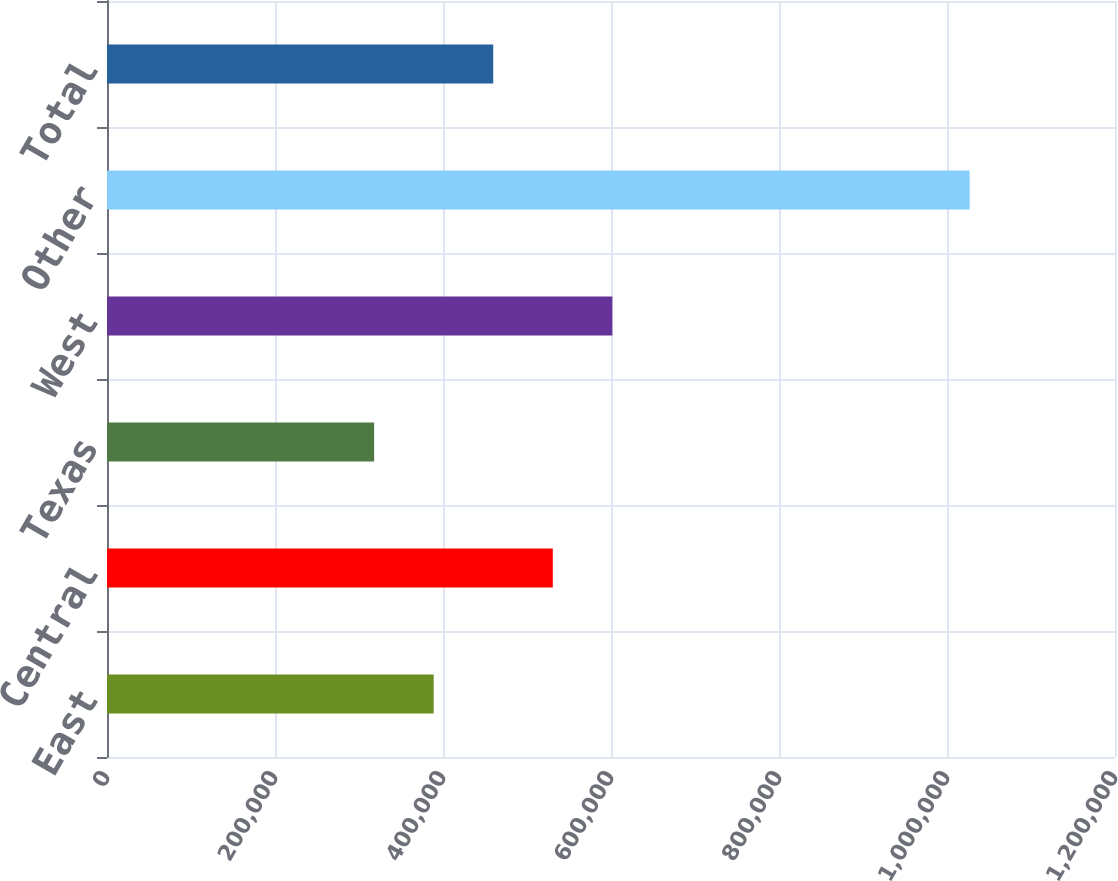Convert chart to OTSL. <chart><loc_0><loc_0><loc_500><loc_500><bar_chart><fcel>East<fcel>Central<fcel>Texas<fcel>West<fcel>Other<fcel>Total<nl><fcel>388900<fcel>530700<fcel>318000<fcel>601600<fcel>1.027e+06<fcel>459800<nl></chart> 